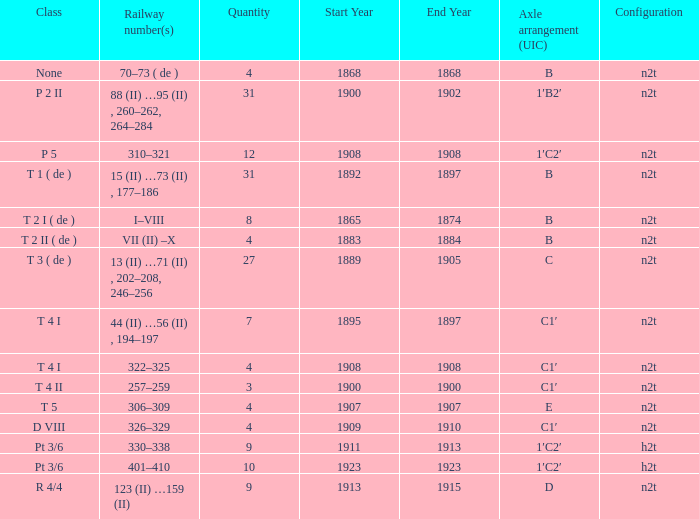What year was the b n2t axle arrangement, which has a quantity of 31, manufactured? 1892–1897. 